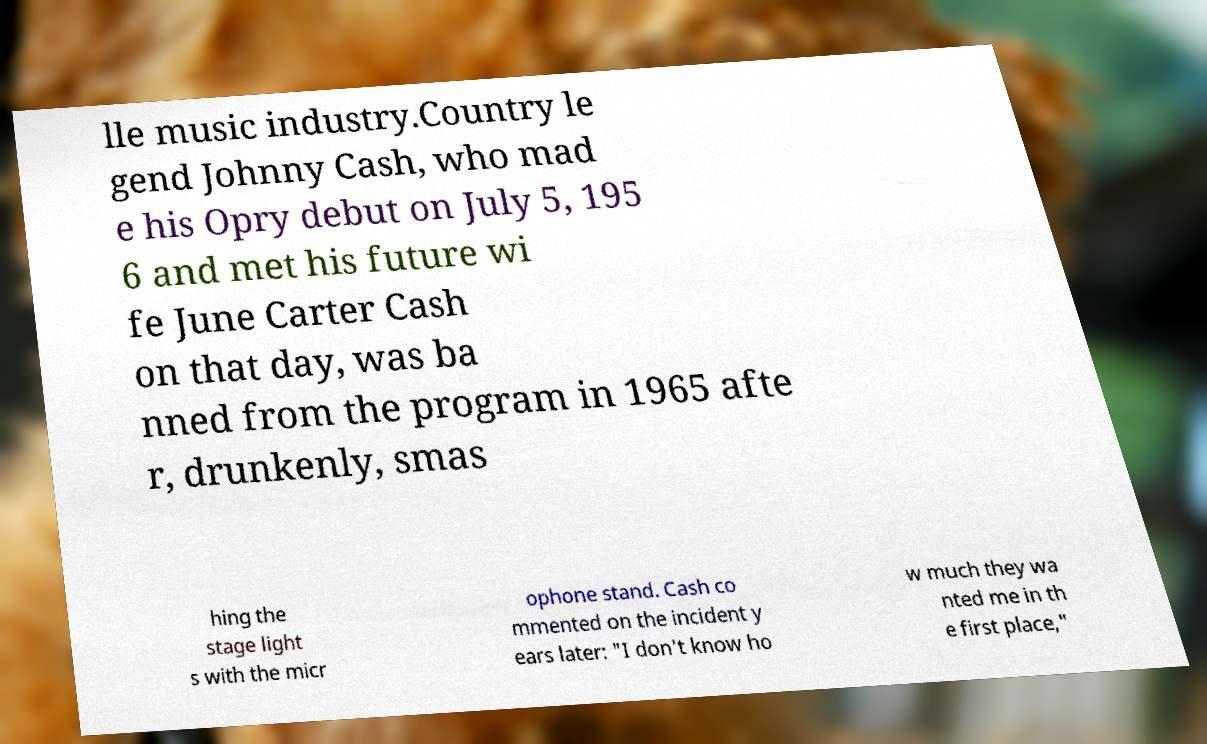I need the written content from this picture converted into text. Can you do that? lle music industry.Country le gend Johnny Cash, who mad e his Opry debut on July 5, 195 6 and met his future wi fe June Carter Cash on that day, was ba nned from the program in 1965 afte r, drunkenly, smas hing the stage light s with the micr ophone stand. Cash co mmented on the incident y ears later: "I don't know ho w much they wa nted me in th e first place," 